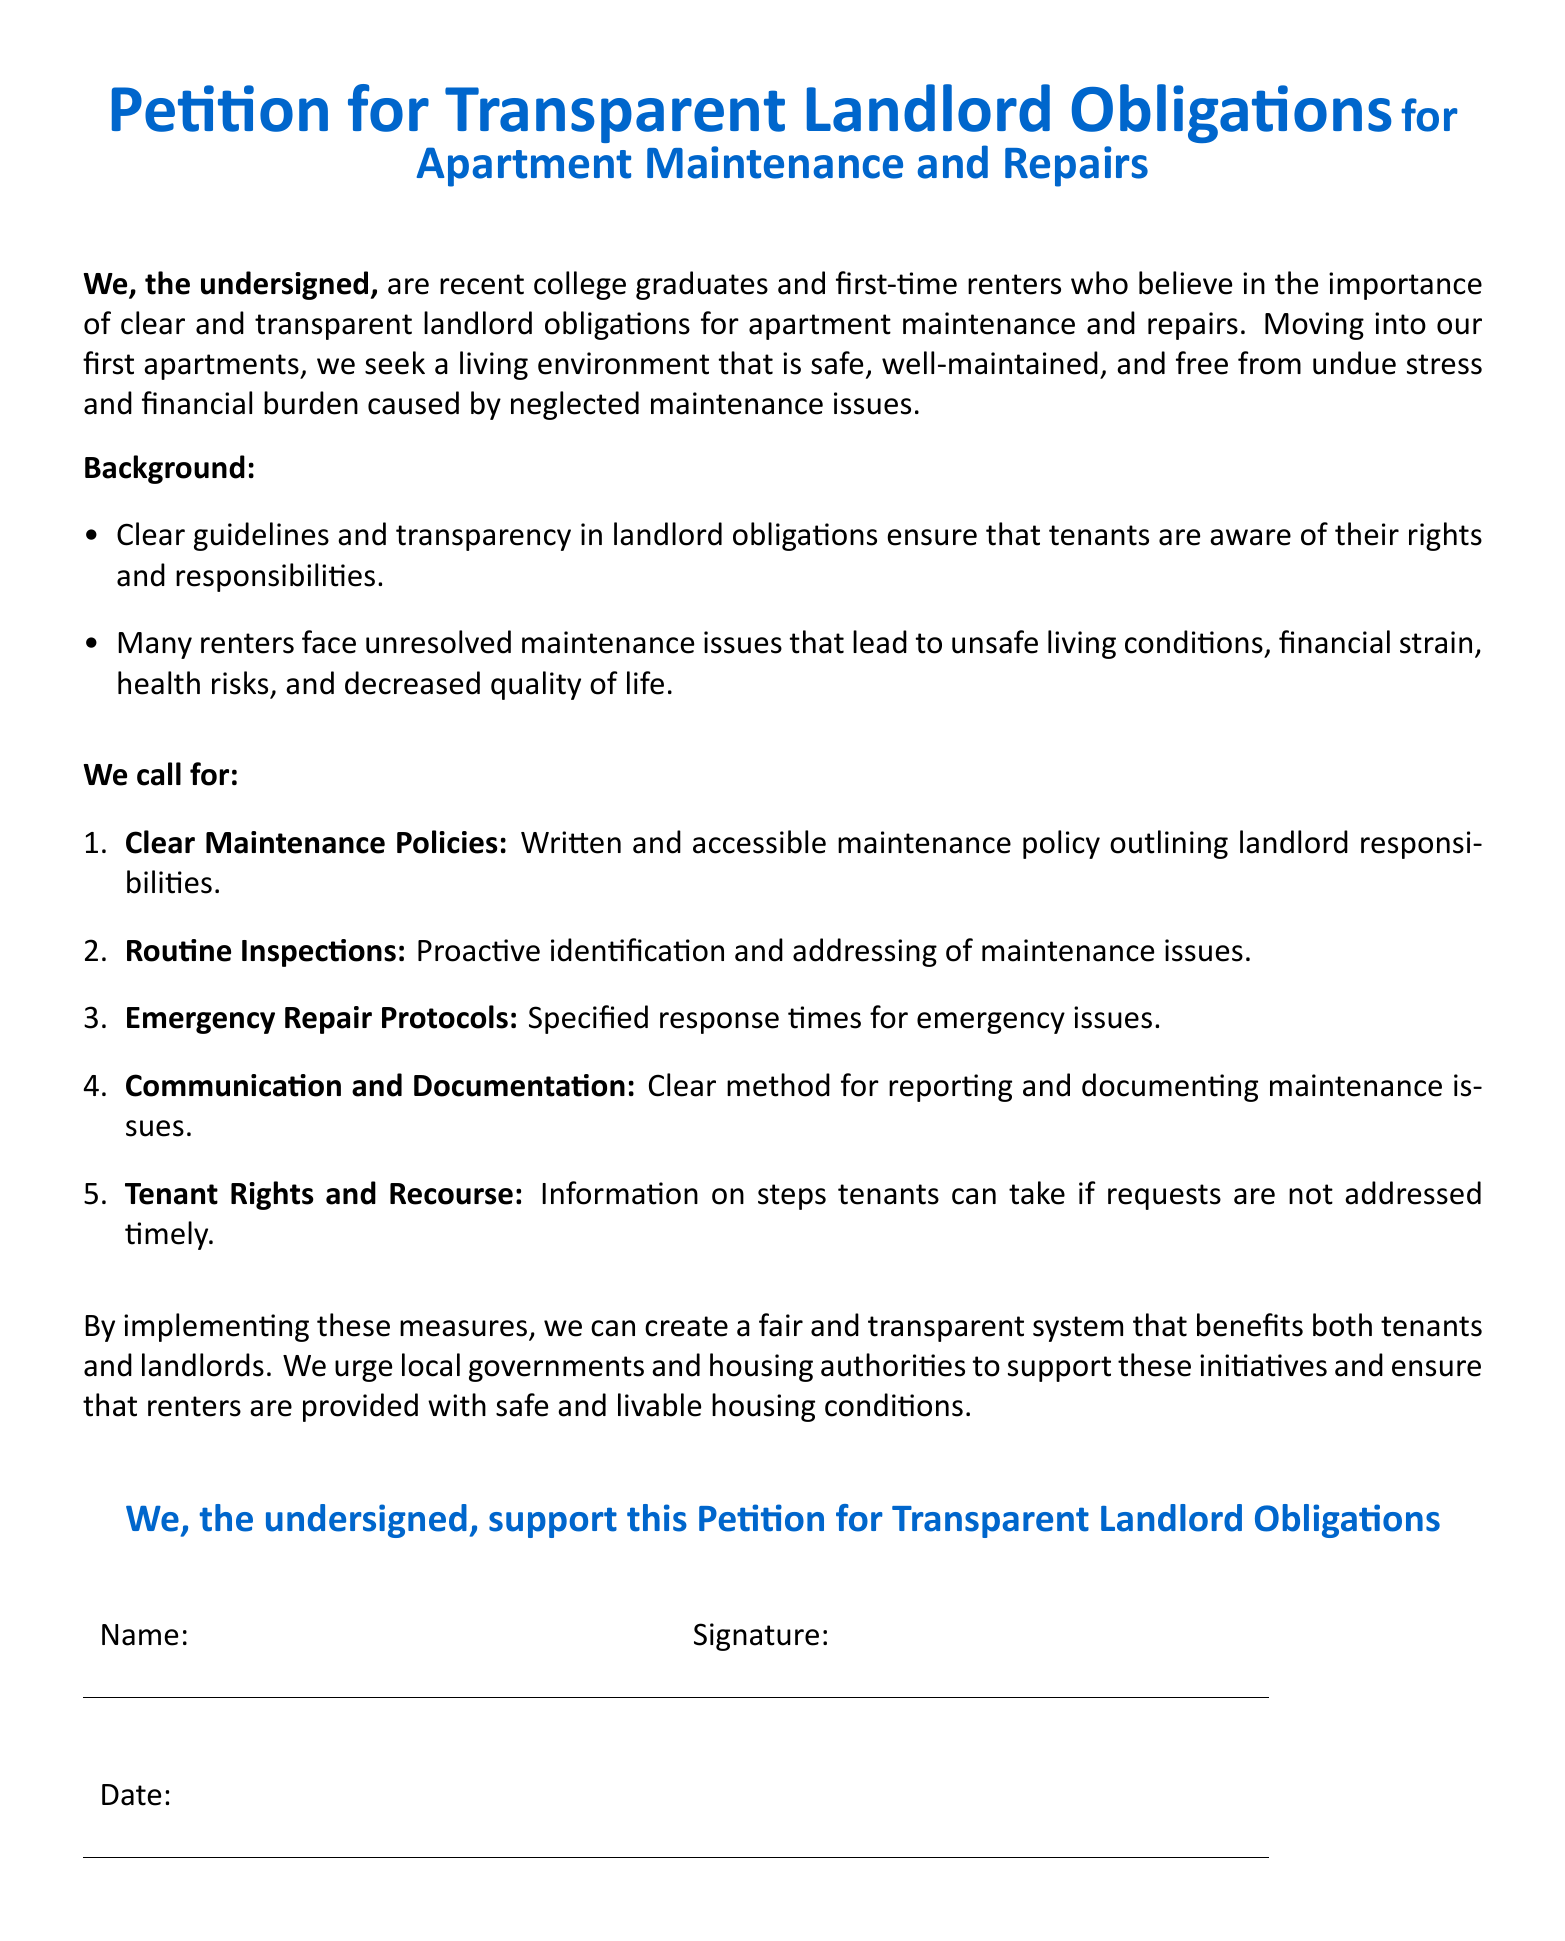What is the main purpose of the petition? The main purpose is to advocate for clear and transparent landlord obligations regarding apartment maintenance and repairs.
Answer: To advocate for clear and transparent landlord obligations Who are the primary supporters of the petition? The petition is supported by recent college graduates and first-time renters.
Answer: Recent college graduates and first-time renters What is one of the key calls to action in the petition? The petition calls for clear maintenance policies outlining landlord responsibilities.
Answer: Clear Maintenance Policies How many main points are called for in the petition? There are five main points outlined in the call for action.
Answer: Five What document structure is used for the signatures? The document includes a table for names and signatures.
Answer: A table What issue do many renters face according to the background section? Many renters face unresolved maintenance issues leading to unsafe living conditions.
Answer: Unresolved maintenance issues What color is used for the title of the petition? The title of the petition is in a main color that is RGB 0,102,204.
Answer: RGB 0,102,204 What do the undersigned urge local governments to support? The undersigned urge local governments to support initiatives for safe and livable housing conditions.
Answer: Initiatives for safe and livable housing conditions 